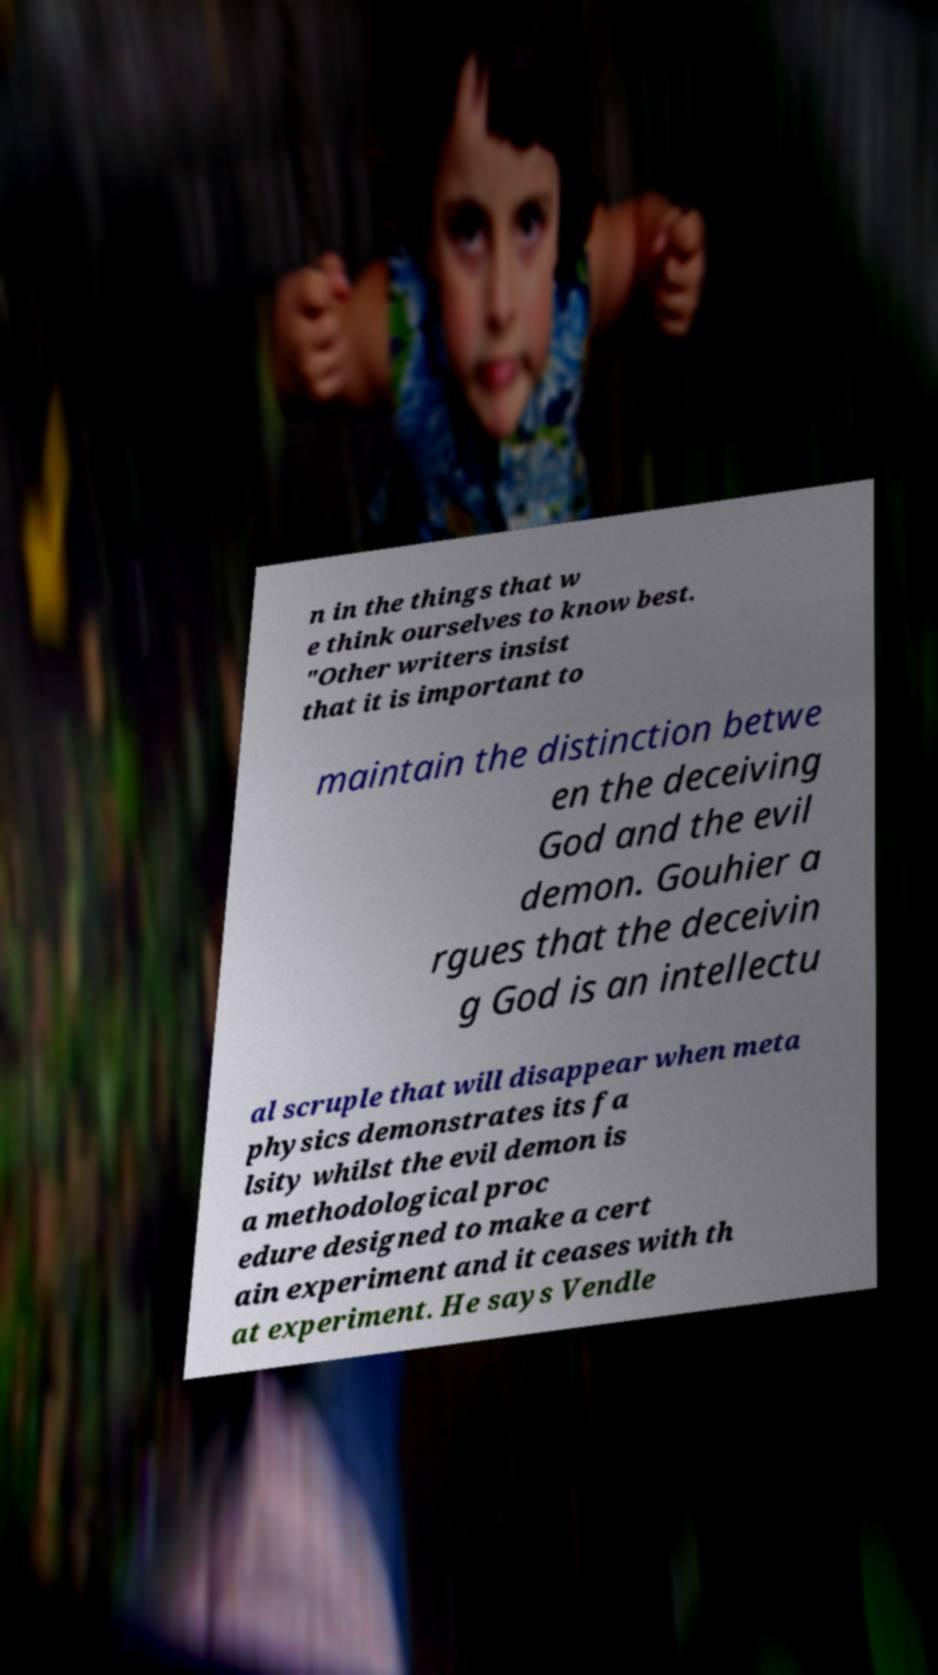Please identify and transcribe the text found in this image. n in the things that w e think ourselves to know best. "Other writers insist that it is important to maintain the distinction betwe en the deceiving God and the evil demon. Gouhier a rgues that the deceivin g God is an intellectu al scruple that will disappear when meta physics demonstrates its fa lsity whilst the evil demon is a methodological proc edure designed to make a cert ain experiment and it ceases with th at experiment. He says Vendle 